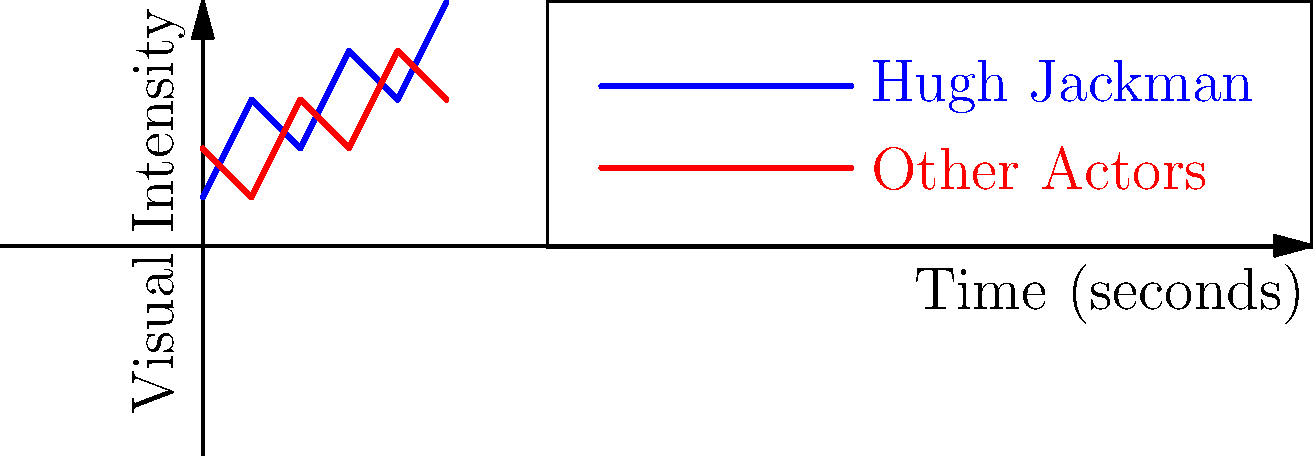Analyze the frame diagram representing the visual intensity of Wolverine fight scenes over time. How does Hugh Jackman's portrayal compare to other actors in terms of maintaining consistent high-intensity action? To analyze the visual intensity of Wolverine fight scenes:

1. Observe the blue line (Hugh Jackman) and the red line (Other Actors) on the graph.
2. Note that the y-axis represents "Visual Intensity" and the x-axis represents "Time (seconds)".
3. Hugh Jackman's line (blue) shows more fluctuations and generally higher peaks:
   - Starts at intensity 1, rises to 3, drops to 2, peaks at 4, drops to 3, ends at 5.
4. Other Actors' line (red) shows less variation:
   - Starts at intensity 2, drops to 1, rises to 3, drops to 2, rises to 4, ends at 3.
5. Calculate the average intensity for each:
   - Hugh Jackman: $(1+3+2+4+3+5)/6 = 3$
   - Other Actors: $(2+1+3+2+4+3)/6 = 2.5$
6. Observe that Hugh Jackman's line ends higher (at 5) compared to Other Actors (at 3).
7. Notice that Hugh Jackman's line has more peaks and valleys, indicating more dynamic action.

Based on this analysis, Hugh Jackman's portrayal shows higher overall intensity, more dynamic action sequences, and a stronger finish compared to other actors. This suggests that Jackman's Wolverine maintains more consistent high-intensity action throughout the analyzed fight scenes.
Answer: Hugh Jackman's portrayal shows higher average intensity (3 vs 2.5) and more dynamic action, maintaining more consistent high-intensity throughout fight scenes. 